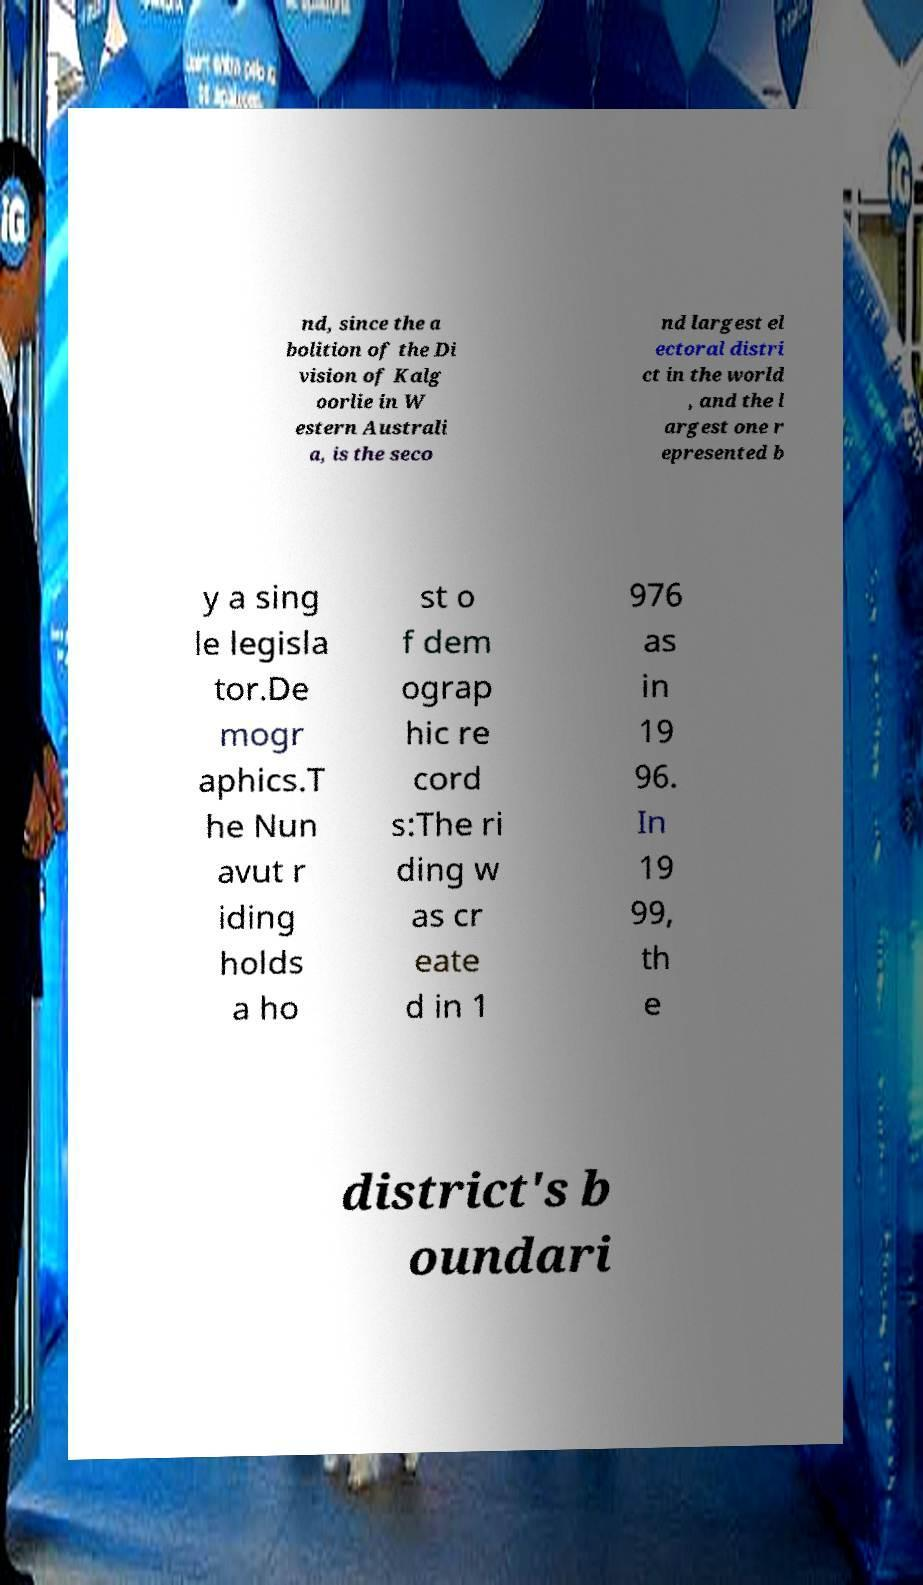For documentation purposes, I need the text within this image transcribed. Could you provide that? nd, since the a bolition of the Di vision of Kalg oorlie in W estern Australi a, is the seco nd largest el ectoral distri ct in the world , and the l argest one r epresented b y a sing le legisla tor.De mogr aphics.T he Nun avut r iding holds a ho st o f dem ograp hic re cord s:The ri ding w as cr eate d in 1 976 as in 19 96. In 19 99, th e district's b oundari 